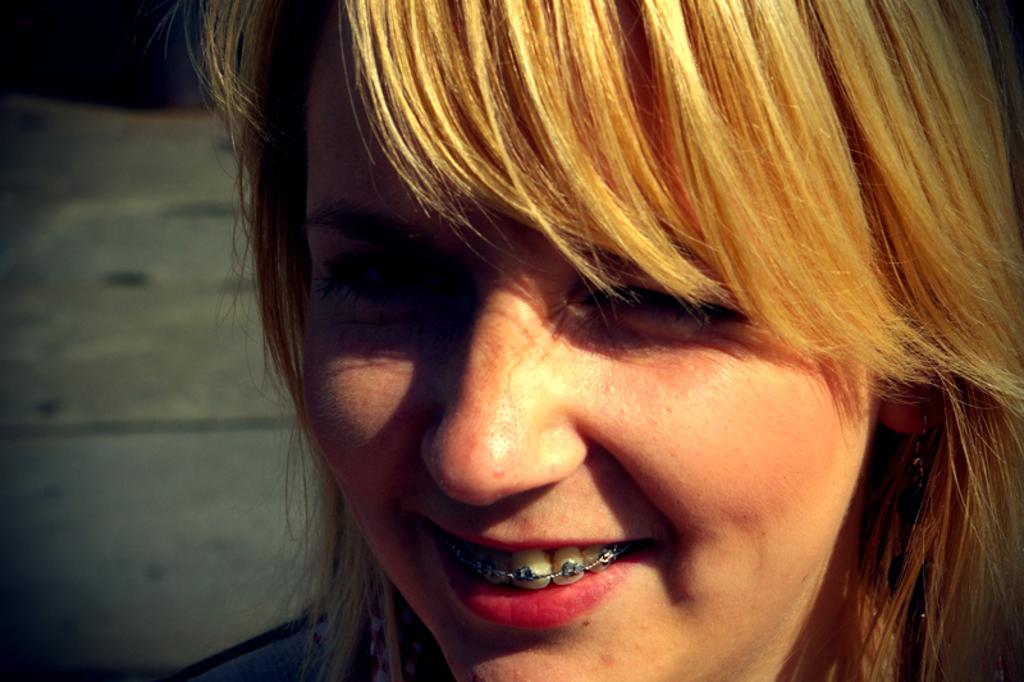Who is the main subject in the image? There is a woman in the image. What is a noticeable feature of the woman's appearance? The woman has brown hair. Are there any dental appliances visible on the woman? Yes, the woman has braces on her teeth. What is the woman's facial expression in the image? The woman is smiling. What level of the building is the woman standing on in the image? There is no building present in the image, and the woman's location is not specified in terms of levels. What type of test is the woman taking in the image? There is no test visible in the image, and the woman's actions are not related to taking a test. 